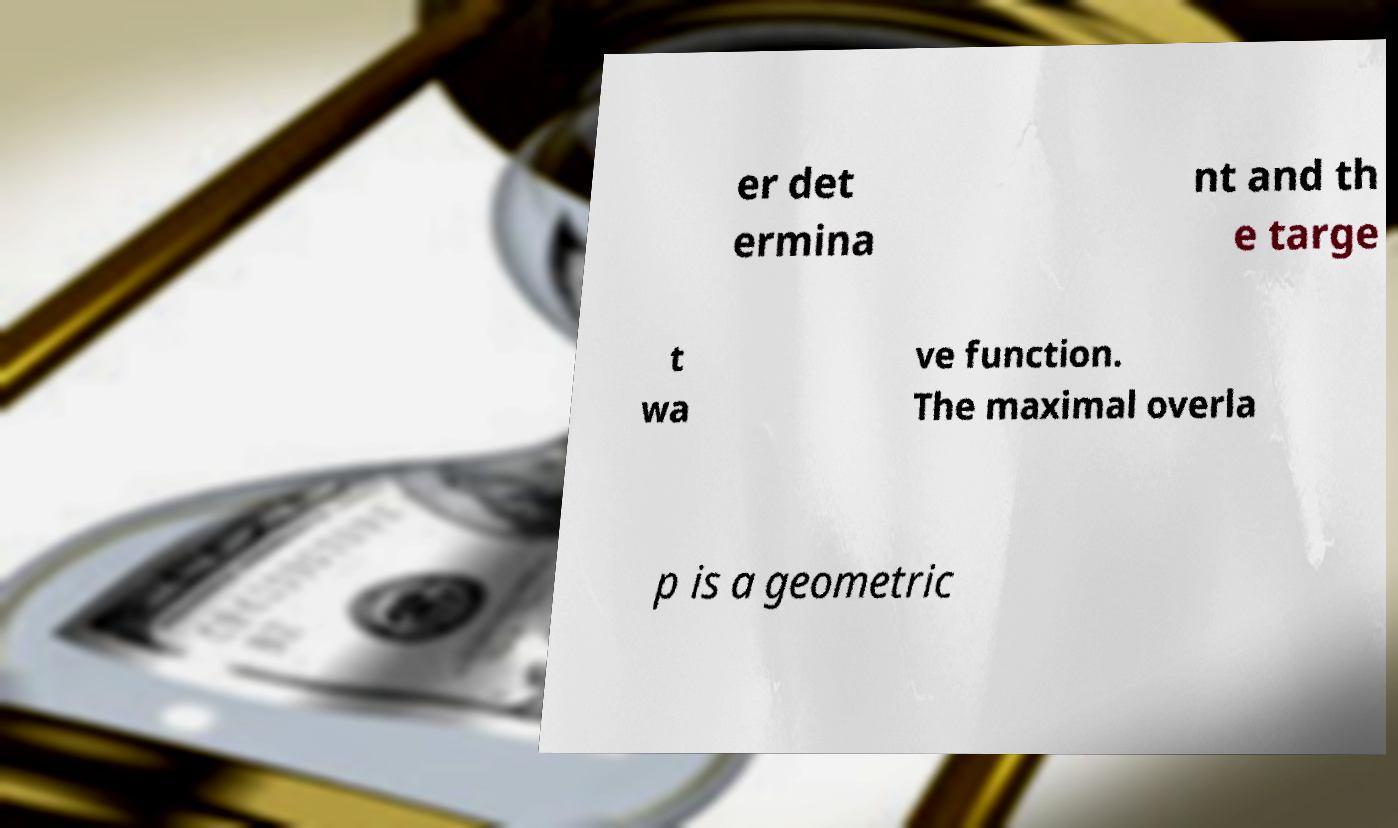What messages or text are displayed in this image? I need them in a readable, typed format. er det ermina nt and th e targe t wa ve function. The maximal overla p is a geometric 